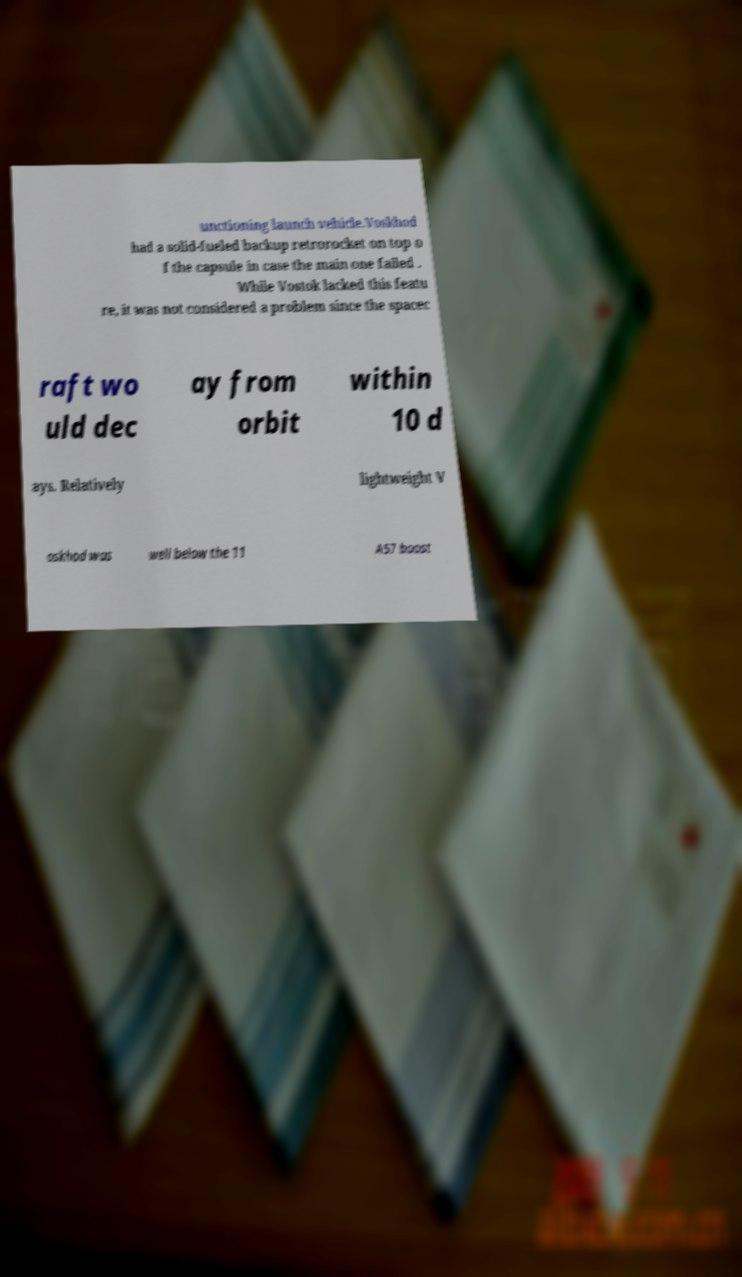There's text embedded in this image that I need extracted. Can you transcribe it verbatim? unctioning launch vehicle.Voskhod had a solid-fueled backup retrorocket on top o f the capsule in case the main one failed . While Vostok lacked this featu re, it was not considered a problem since the spacec raft wo uld dec ay from orbit within 10 d ays. Relatively lightweight V oskhod was well below the 11 A57 boost 